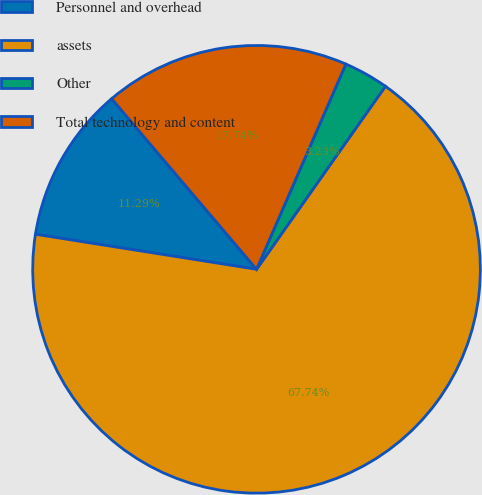Convert chart. <chart><loc_0><loc_0><loc_500><loc_500><pie_chart><fcel>Personnel and overhead<fcel>assets<fcel>Other<fcel>Total technology and content<nl><fcel>11.29%<fcel>67.74%<fcel>3.23%<fcel>17.74%<nl></chart> 